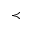<formula> <loc_0><loc_0><loc_500><loc_500>\prec</formula> 